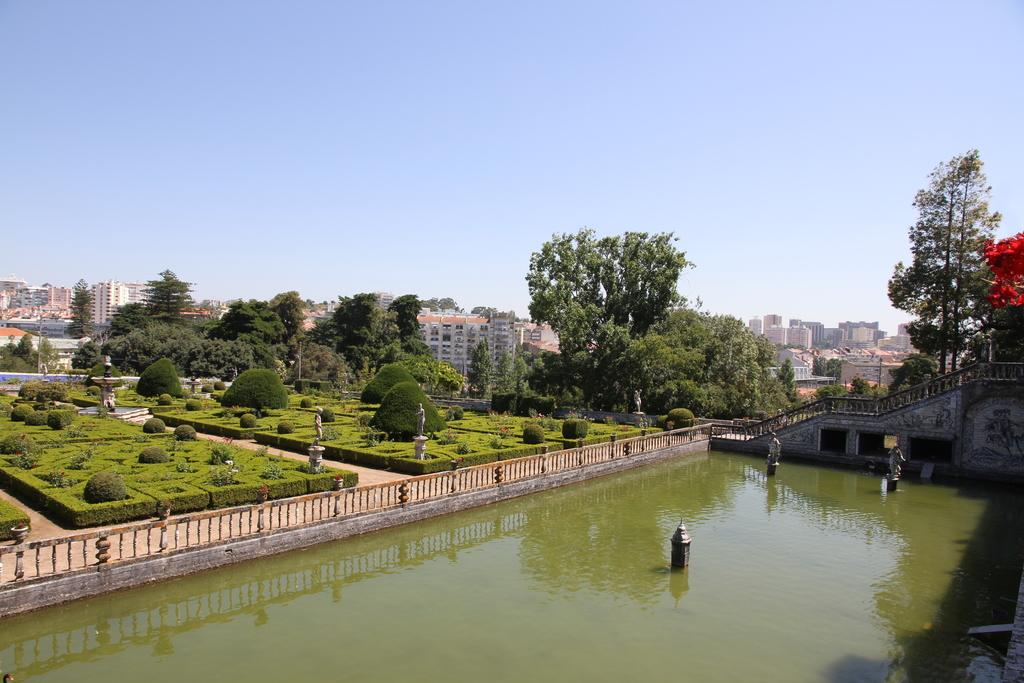What type of structures can be seen in the image? There are buildings in the image. What natural elements are present in the image? There are trees and plants in the image. What can be seen in the water in the image? There is no information about what can be seen in the water. What type of barrier is present in the image? There is a fence in the image. What type of artwork can be seen in the image? There are statues in the image. What is visible in the background of the image? The sky is visible in the background of the image. What type of nerve is visible in the image? There is no mention of a nerve in the image; it contains buildings, trees, plants, water, a fence, statues, and the sky. What type of yam is being used as a prop in the image? There is no yam present in the image. 